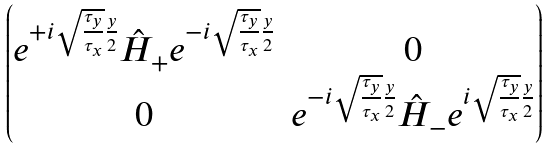Convert formula to latex. <formula><loc_0><loc_0><loc_500><loc_500>\begin{pmatrix} e ^ { + i \sqrt { \frac { \tau _ { y } } { \tau _ { x } } } \frac { y } { 2 } } \hat { H } _ { + } e ^ { - i \sqrt { \frac { \tau _ { y } } { \tau _ { x } } } \frac { y } { 2 } } & 0 \\ 0 & e ^ { - i \sqrt { \frac { \tau _ { y } } { \tau _ { x } } } \frac { y } { 2 } } \hat { H } _ { - } e ^ { i \sqrt { \frac { \tau _ { y } } { \tau _ { x } } } \frac { y } { 2 } } \end{pmatrix}</formula> 